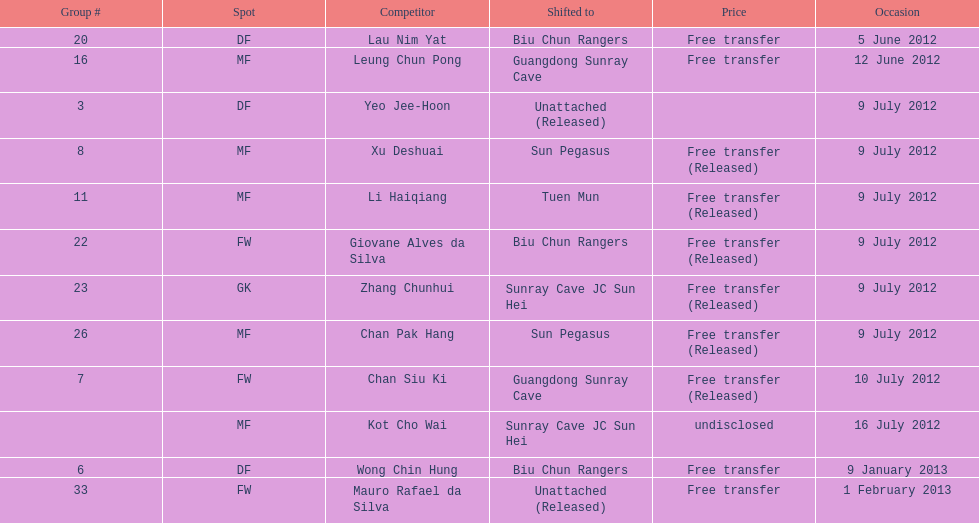Which team did lau nim yat play for after he was transferred? Biu Chun Rangers. Give me the full table as a dictionary. {'header': ['Group #', 'Spot', 'Competitor', 'Shifted to', 'Price', 'Occasion'], 'rows': [['20', 'DF', 'Lau Nim Yat', 'Biu Chun Rangers', 'Free transfer', '5 June 2012'], ['16', 'MF', 'Leung Chun Pong', 'Guangdong Sunray Cave', 'Free transfer', '12 June 2012'], ['3', 'DF', 'Yeo Jee-Hoon', 'Unattached (Released)', '', '9 July 2012'], ['8', 'MF', 'Xu Deshuai', 'Sun Pegasus', 'Free transfer (Released)', '9 July 2012'], ['11', 'MF', 'Li Haiqiang', 'Tuen Mun', 'Free transfer (Released)', '9 July 2012'], ['22', 'FW', 'Giovane Alves da Silva', 'Biu Chun Rangers', 'Free transfer (Released)', '9 July 2012'], ['23', 'GK', 'Zhang Chunhui', 'Sunray Cave JC Sun Hei', 'Free transfer (Released)', '9 July 2012'], ['26', 'MF', 'Chan Pak Hang', 'Sun Pegasus', 'Free transfer (Released)', '9 July 2012'], ['7', 'FW', 'Chan Siu Ki', 'Guangdong Sunray Cave', 'Free transfer (Released)', '10 July 2012'], ['', 'MF', 'Kot Cho Wai', 'Sunray Cave JC Sun Hei', 'undisclosed', '16 July 2012'], ['6', 'DF', 'Wong Chin Hung', 'Biu Chun Rangers', 'Free transfer', '9 January 2013'], ['33', 'FW', 'Mauro Rafael da Silva', 'Unattached (Released)', 'Free transfer', '1 February 2013']]} 